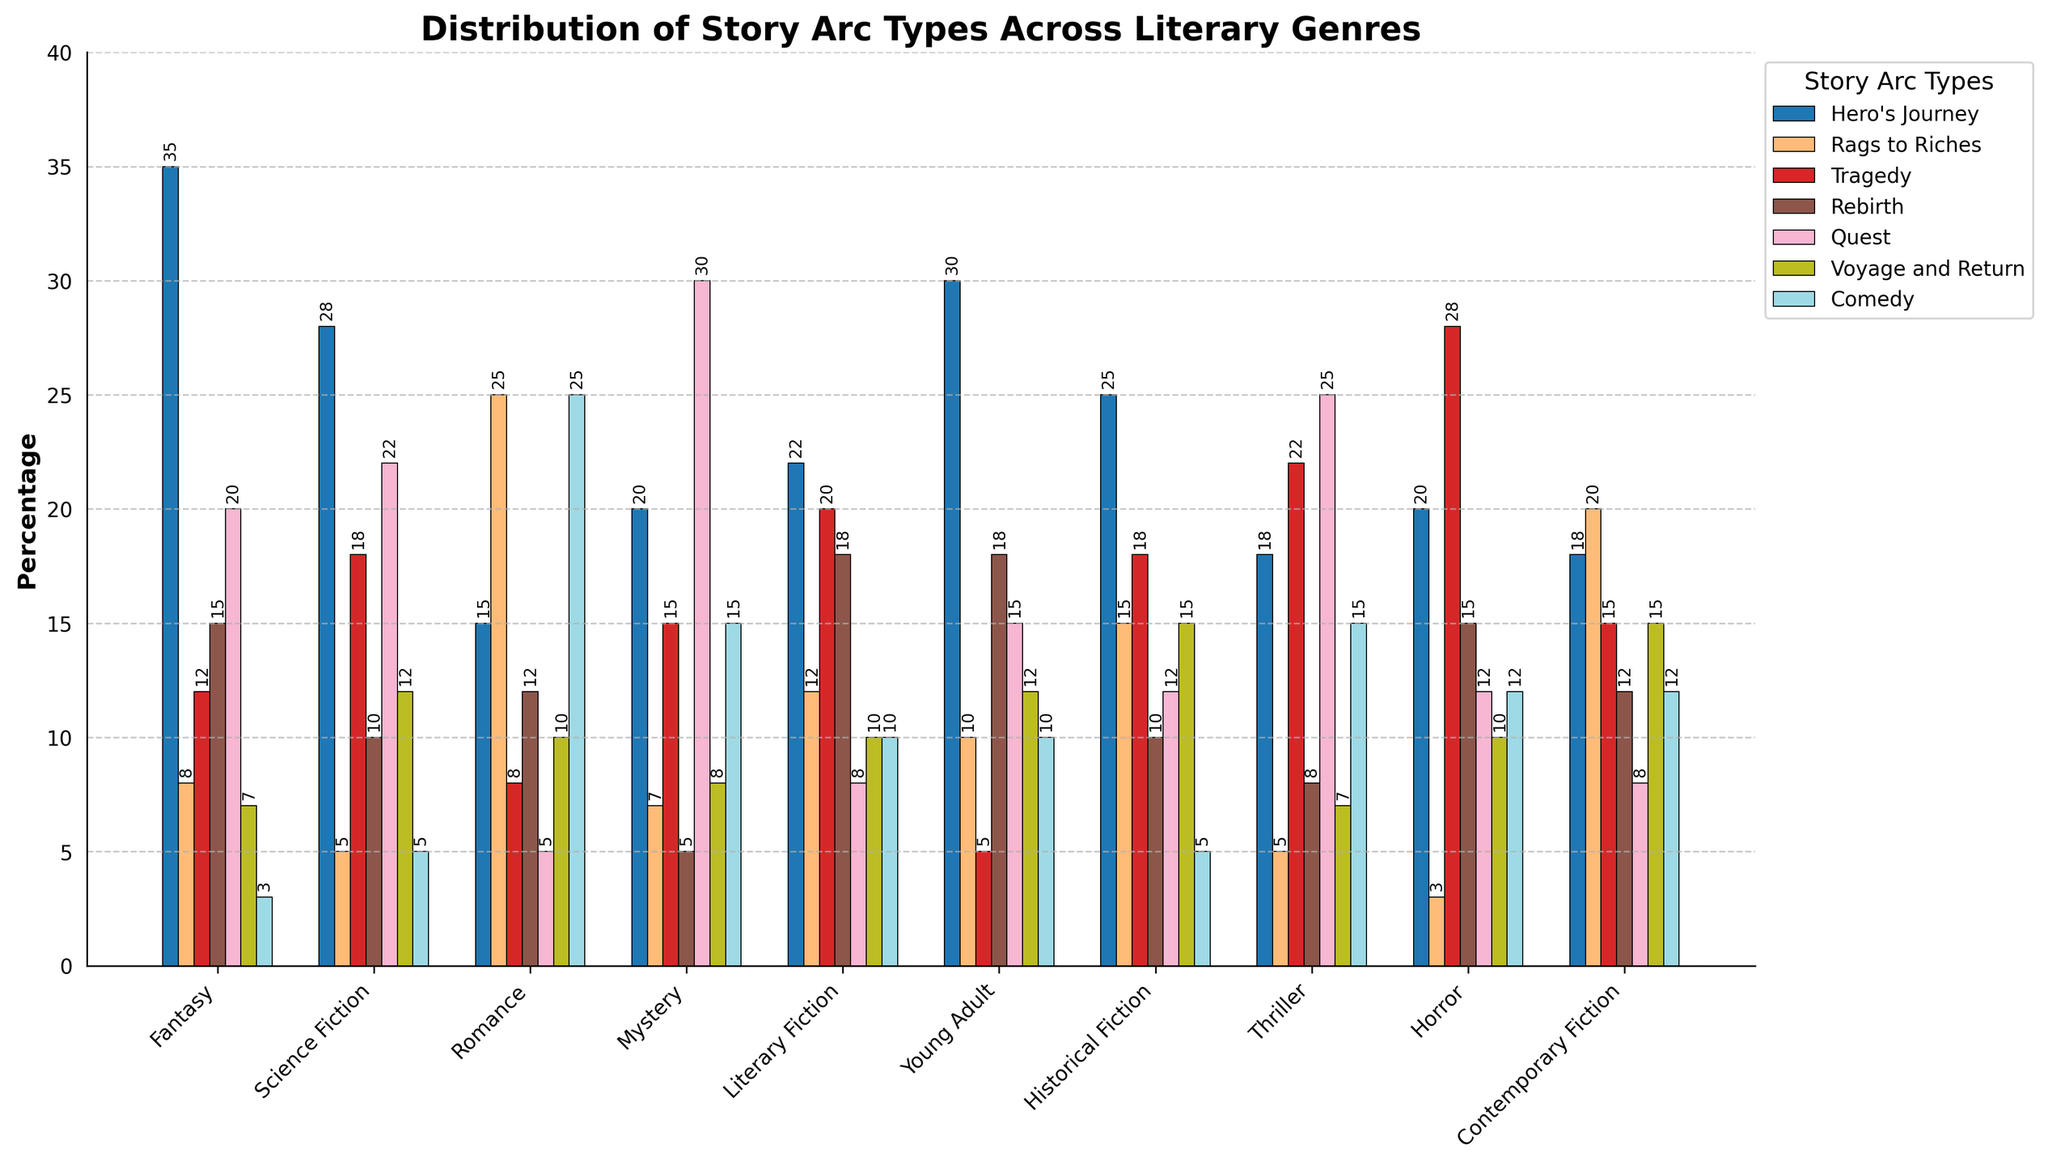Which genre has the highest percentage of the "Hero's Journey" arc type? By examining the height of the bars representing the "Hero's Journey" across genres, it is evident that Fantasy has the tallest bar.
Answer: Fantasy Which story arc type is most prevalent in Romance? The tallest bar in the Romance genre corresponds to the "Rags to Riches" arc type.
Answer: Rags to Riches What is the difference in the percentage of "Comedy" arc types between Romance and Historical Fiction? The bar heights for "Comedy" in Romance and Historical Fiction are 25 and 5, respectively. The difference is calculated as 25 - 5.
Answer: 20 Between Mystery and Science Fiction, which genre has a higher percentage of the "Quest" arc type, and by how much? The height of the "Quest" bar in Mystery is 30, while in Science Fiction it is 22. Mystery has a higher percentage, and the difference is 30 - 22.
Answer: Mystery, 8 Are the percentages for the "Rebirth" arc type higher in Literary Fiction or Horror? By comparing the heights of the "Rebirth" bars for Literary Fiction and Horror, we see that Literary Fiction has a taller bar at 18 compared to Horror at 15.
Answer: Literary Fiction What is the average percentage of the "Voyage and Return" arc type across all genres shown? Summing up the "Voyage and Return" percentages (7 + 12 + 10 + 8 + 10 + 12 + 15 + 7 + 10 + 15) = 106, and dividing by the number of genres (10), the average is 106 / 10.
Answer: 10.6 Which two story arc types are equally prevalent in Thriller, and what is their percentage? By looking at the bars for Thriller, we see that "Comedy" and "Rags to Riches" both have heights of 15.
Answer: Comedy and Rags to Riches, 15 What is the sum of the percentages of "Tragedy" and "Rebirth" arc types in Science Fiction? The heights of the bars for "Tragedy" and "Rebirth" in Science Fiction are 18 and 10, respectively. The sum is 18 + 10.
Answer: 28 How many genres have a higher percentage of the "Hero's Journey" arc type than "Rags to Riches"? Compare the heights of the "Hero's Journey" and "Rags to Riches" bars across all genres. Fantasy, Science Fiction, Young Adult, and Thriller have higher percentages for "Hero's Journey" than for "Rags to Riches". So there are 4 genres.
Answer: 4 In which genre is the combination of "Rebirth" and "Quest" arc types most common, and what is the combined percentage? Add the heights of the "Rebirth" and "Quest" bars in each genre and compare. For Literary Fiction, the combined height is 18 + 8 = 26. This value is the highest among genres, making Literary Fiction the most common.
Answer: Literary Fiction, 26 